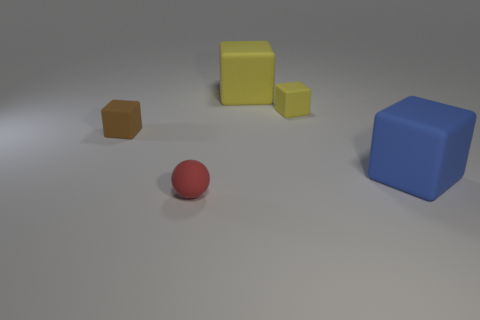How many other things are made of the same material as the tiny brown block?
Provide a short and direct response. 4. Is the tiny ball made of the same material as the brown block?
Give a very brief answer. Yes. How many other things are the same size as the blue cube?
Offer a very short reply. 1. There is a yellow thing that is behind the small object on the right side of the tiny red object; what size is it?
Offer a very short reply. Large. What color is the tiny cube on the right side of the small rubber object in front of the tiny thing that is on the left side of the small red rubber object?
Your response must be concise. Yellow. There is a cube that is in front of the tiny yellow cube and on the right side of the brown rubber thing; how big is it?
Offer a very short reply. Large. How many other objects are there of the same shape as the tiny brown thing?
Make the answer very short. 3. How many cylinders are large green metal things or large rubber things?
Make the answer very short. 0. Is there a yellow cube behind the small rubber cube to the left of the big object that is behind the blue cube?
Provide a succinct answer. Yes. What is the color of the other tiny rubber thing that is the same shape as the small brown matte object?
Give a very brief answer. Yellow. 